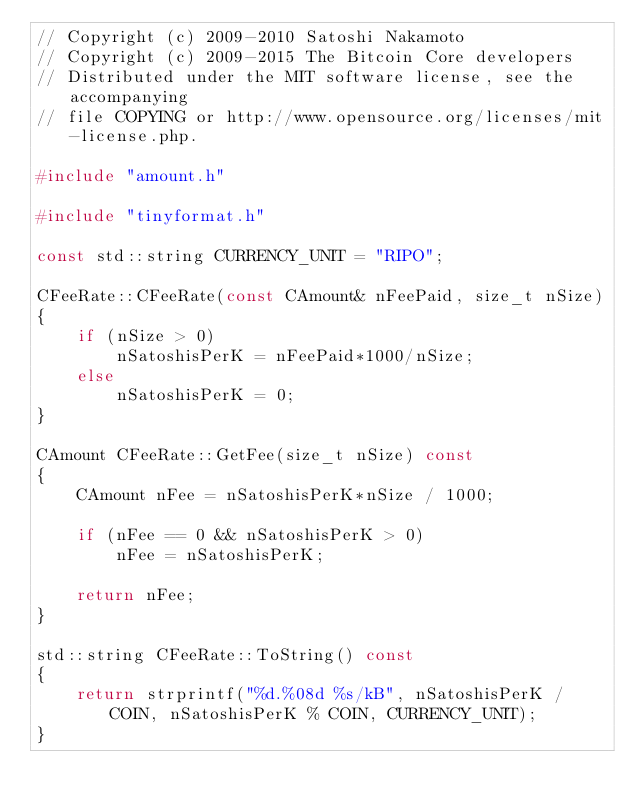<code> <loc_0><loc_0><loc_500><loc_500><_C++_>// Copyright (c) 2009-2010 Satoshi Nakamoto
// Copyright (c) 2009-2015 The Bitcoin Core developers
// Distributed under the MIT software license, see the accompanying
// file COPYING or http://www.opensource.org/licenses/mit-license.php.

#include "amount.h"

#include "tinyformat.h"

const std::string CURRENCY_UNIT = "RIPO";

CFeeRate::CFeeRate(const CAmount& nFeePaid, size_t nSize)
{
    if (nSize > 0)
        nSatoshisPerK = nFeePaid*1000/nSize;
    else
        nSatoshisPerK = 0;
}

CAmount CFeeRate::GetFee(size_t nSize) const
{
    CAmount nFee = nSatoshisPerK*nSize / 1000;

    if (nFee == 0 && nSatoshisPerK > 0)
        nFee = nSatoshisPerK;

    return nFee;
}

std::string CFeeRate::ToString() const
{
    return strprintf("%d.%08d %s/kB", nSatoshisPerK / COIN, nSatoshisPerK % COIN, CURRENCY_UNIT);
}
</code> 